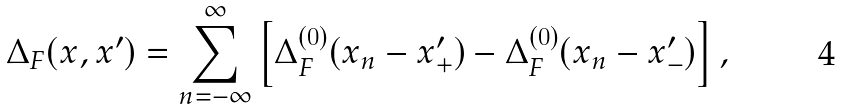Convert formula to latex. <formula><loc_0><loc_0><loc_500><loc_500>\Delta _ { F } ( x , x ^ { \prime } ) = \sum _ { n = - \infty } ^ { \infty } \left [ \Delta _ { F } ^ { ( 0 ) } ( x _ { n } - x _ { + } ^ { \prime } ) - \Delta _ { F } ^ { ( 0 ) } ( x _ { n } - x _ { - } ^ { \prime } ) \right ] ,</formula> 